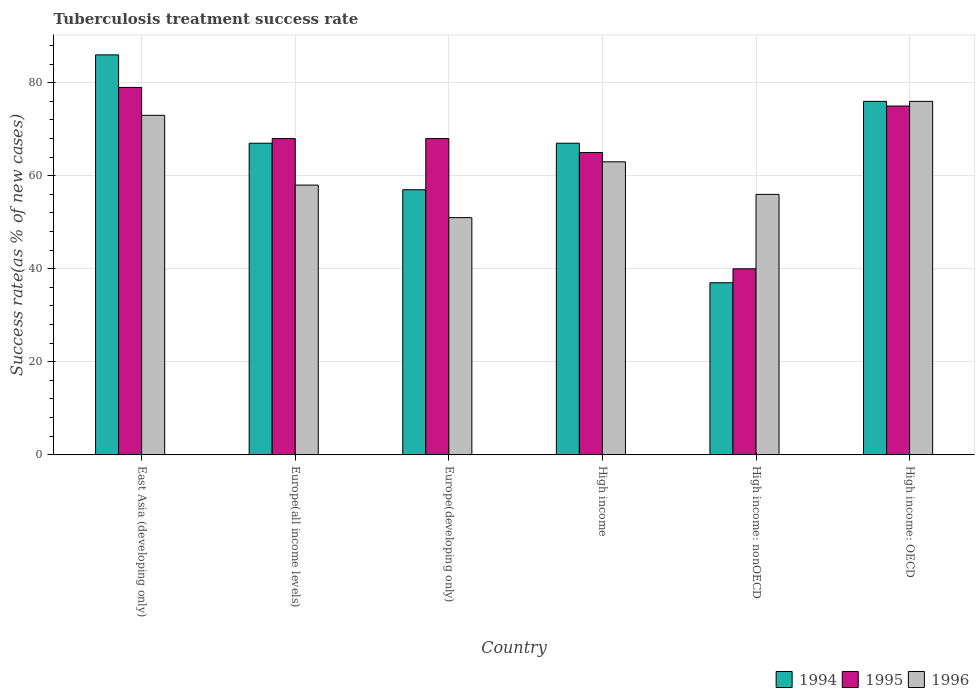How many different coloured bars are there?
Provide a short and direct response. 3. How many groups of bars are there?
Offer a very short reply. 6. Are the number of bars on each tick of the X-axis equal?
Keep it short and to the point. Yes. How many bars are there on the 3rd tick from the right?
Your answer should be compact. 3. What is the label of the 5th group of bars from the left?
Make the answer very short. High income: nonOECD. What is the tuberculosis treatment success rate in 1994 in High income: OECD?
Your answer should be very brief. 76. Across all countries, what is the maximum tuberculosis treatment success rate in 1994?
Your answer should be very brief. 86. In which country was the tuberculosis treatment success rate in 1996 maximum?
Provide a short and direct response. High income: OECD. In which country was the tuberculosis treatment success rate in 1994 minimum?
Provide a short and direct response. High income: nonOECD. What is the total tuberculosis treatment success rate in 1996 in the graph?
Offer a terse response. 377. What is the average tuberculosis treatment success rate in 1996 per country?
Offer a very short reply. 62.83. What is the difference between the tuberculosis treatment success rate of/in 1994 and tuberculosis treatment success rate of/in 1995 in High income: nonOECD?
Keep it short and to the point. -3. What is the ratio of the tuberculosis treatment success rate in 1995 in East Asia (developing only) to that in High income: nonOECD?
Provide a succinct answer. 1.98. What is the difference between the highest and the second highest tuberculosis treatment success rate in 1994?
Provide a short and direct response. -9. In how many countries, is the tuberculosis treatment success rate in 1995 greater than the average tuberculosis treatment success rate in 1995 taken over all countries?
Make the answer very short. 4. Is the sum of the tuberculosis treatment success rate in 1995 in Europe(developing only) and High income greater than the maximum tuberculosis treatment success rate in 1994 across all countries?
Your answer should be very brief. Yes. What does the 1st bar from the right in High income: nonOECD represents?
Give a very brief answer. 1996. How many countries are there in the graph?
Keep it short and to the point. 6. Does the graph contain any zero values?
Make the answer very short. No. How are the legend labels stacked?
Give a very brief answer. Horizontal. What is the title of the graph?
Provide a succinct answer. Tuberculosis treatment success rate. Does "2004" appear as one of the legend labels in the graph?
Your response must be concise. No. What is the label or title of the X-axis?
Give a very brief answer. Country. What is the label or title of the Y-axis?
Provide a short and direct response. Success rate(as % of new cases). What is the Success rate(as % of new cases) in 1994 in East Asia (developing only)?
Keep it short and to the point. 86. What is the Success rate(as % of new cases) in 1995 in East Asia (developing only)?
Provide a succinct answer. 79. What is the Success rate(as % of new cases) of 1994 in Europe(all income levels)?
Provide a short and direct response. 67. What is the Success rate(as % of new cases) of 1995 in Europe(all income levels)?
Offer a terse response. 68. What is the Success rate(as % of new cases) in 1996 in Europe(all income levels)?
Offer a terse response. 58. What is the Success rate(as % of new cases) of 1996 in Europe(developing only)?
Offer a very short reply. 51. What is the Success rate(as % of new cases) of 1995 in High income?
Ensure brevity in your answer.  65. What is the Success rate(as % of new cases) in 1996 in High income?
Offer a very short reply. 63. What is the Success rate(as % of new cases) in 1996 in High income: nonOECD?
Ensure brevity in your answer.  56. What is the Success rate(as % of new cases) in 1994 in High income: OECD?
Make the answer very short. 76. Across all countries, what is the maximum Success rate(as % of new cases) in 1995?
Offer a terse response. 79. Across all countries, what is the maximum Success rate(as % of new cases) of 1996?
Provide a succinct answer. 76. Across all countries, what is the minimum Success rate(as % of new cases) of 1994?
Your answer should be very brief. 37. What is the total Success rate(as % of new cases) of 1994 in the graph?
Provide a succinct answer. 390. What is the total Success rate(as % of new cases) of 1995 in the graph?
Keep it short and to the point. 395. What is the total Success rate(as % of new cases) in 1996 in the graph?
Keep it short and to the point. 377. What is the difference between the Success rate(as % of new cases) in 1996 in East Asia (developing only) and that in Europe(all income levels)?
Your answer should be very brief. 15. What is the difference between the Success rate(as % of new cases) in 1995 in East Asia (developing only) and that in High income?
Your answer should be very brief. 14. What is the difference between the Success rate(as % of new cases) in 1996 in East Asia (developing only) and that in High income?
Your answer should be compact. 10. What is the difference between the Success rate(as % of new cases) of 1996 in East Asia (developing only) and that in High income: nonOECD?
Offer a terse response. 17. What is the difference between the Success rate(as % of new cases) of 1994 in East Asia (developing only) and that in High income: OECD?
Offer a terse response. 10. What is the difference between the Success rate(as % of new cases) of 1995 in East Asia (developing only) and that in High income: OECD?
Make the answer very short. 4. What is the difference between the Success rate(as % of new cases) in 1994 in Europe(all income levels) and that in High income?
Your answer should be compact. 0. What is the difference between the Success rate(as % of new cases) in 1995 in Europe(all income levels) and that in High income?
Keep it short and to the point. 3. What is the difference between the Success rate(as % of new cases) in 1996 in Europe(all income levels) and that in High income: nonOECD?
Your response must be concise. 2. What is the difference between the Success rate(as % of new cases) of 1996 in Europe(all income levels) and that in High income: OECD?
Ensure brevity in your answer.  -18. What is the difference between the Success rate(as % of new cases) of 1994 in Europe(developing only) and that in High income: nonOECD?
Your answer should be compact. 20. What is the difference between the Success rate(as % of new cases) in 1995 in Europe(developing only) and that in High income: nonOECD?
Your response must be concise. 28. What is the difference between the Success rate(as % of new cases) of 1996 in Europe(developing only) and that in High income: nonOECD?
Keep it short and to the point. -5. What is the difference between the Success rate(as % of new cases) in 1994 in Europe(developing only) and that in High income: OECD?
Your answer should be very brief. -19. What is the difference between the Success rate(as % of new cases) of 1996 in Europe(developing only) and that in High income: OECD?
Make the answer very short. -25. What is the difference between the Success rate(as % of new cases) in 1994 in High income and that in High income: nonOECD?
Offer a terse response. 30. What is the difference between the Success rate(as % of new cases) in 1995 in High income and that in High income: nonOECD?
Provide a succinct answer. 25. What is the difference between the Success rate(as % of new cases) of 1996 in High income and that in High income: nonOECD?
Your answer should be very brief. 7. What is the difference between the Success rate(as % of new cases) of 1994 in High income and that in High income: OECD?
Make the answer very short. -9. What is the difference between the Success rate(as % of new cases) in 1995 in High income and that in High income: OECD?
Provide a succinct answer. -10. What is the difference between the Success rate(as % of new cases) in 1994 in High income: nonOECD and that in High income: OECD?
Ensure brevity in your answer.  -39. What is the difference between the Success rate(as % of new cases) of 1995 in High income: nonOECD and that in High income: OECD?
Your answer should be very brief. -35. What is the difference between the Success rate(as % of new cases) of 1994 in East Asia (developing only) and the Success rate(as % of new cases) of 1995 in Europe(all income levels)?
Ensure brevity in your answer.  18. What is the difference between the Success rate(as % of new cases) in 1994 in East Asia (developing only) and the Success rate(as % of new cases) in 1996 in Europe(all income levels)?
Keep it short and to the point. 28. What is the difference between the Success rate(as % of new cases) of 1995 in East Asia (developing only) and the Success rate(as % of new cases) of 1996 in Europe(developing only)?
Provide a short and direct response. 28. What is the difference between the Success rate(as % of new cases) in 1995 in East Asia (developing only) and the Success rate(as % of new cases) in 1996 in High income?
Your response must be concise. 16. What is the difference between the Success rate(as % of new cases) of 1994 in East Asia (developing only) and the Success rate(as % of new cases) of 1995 in High income: nonOECD?
Ensure brevity in your answer.  46. What is the difference between the Success rate(as % of new cases) in 1994 in Europe(all income levels) and the Success rate(as % of new cases) in 1995 in Europe(developing only)?
Offer a terse response. -1. What is the difference between the Success rate(as % of new cases) in 1995 in Europe(all income levels) and the Success rate(as % of new cases) in 1996 in Europe(developing only)?
Ensure brevity in your answer.  17. What is the difference between the Success rate(as % of new cases) in 1994 in Europe(all income levels) and the Success rate(as % of new cases) in 1995 in High income?
Offer a very short reply. 2. What is the difference between the Success rate(as % of new cases) in 1995 in Europe(all income levels) and the Success rate(as % of new cases) in 1996 in High income?
Keep it short and to the point. 5. What is the difference between the Success rate(as % of new cases) of 1994 in Europe(all income levels) and the Success rate(as % of new cases) of 1996 in High income: nonOECD?
Provide a short and direct response. 11. What is the difference between the Success rate(as % of new cases) of 1995 in Europe(all income levels) and the Success rate(as % of new cases) of 1996 in High income: nonOECD?
Provide a succinct answer. 12. What is the difference between the Success rate(as % of new cases) of 1994 in Europe(all income levels) and the Success rate(as % of new cases) of 1995 in High income: OECD?
Give a very brief answer. -8. What is the difference between the Success rate(as % of new cases) in 1995 in Europe(developing only) and the Success rate(as % of new cases) in 1996 in High income?
Ensure brevity in your answer.  5. What is the difference between the Success rate(as % of new cases) of 1994 in Europe(developing only) and the Success rate(as % of new cases) of 1995 in High income: nonOECD?
Provide a succinct answer. 17. What is the difference between the Success rate(as % of new cases) of 1994 in Europe(developing only) and the Success rate(as % of new cases) of 1996 in High income: nonOECD?
Keep it short and to the point. 1. What is the difference between the Success rate(as % of new cases) of 1995 in Europe(developing only) and the Success rate(as % of new cases) of 1996 in High income: OECD?
Offer a terse response. -8. What is the difference between the Success rate(as % of new cases) of 1994 in High income and the Success rate(as % of new cases) of 1995 in High income: nonOECD?
Your answer should be very brief. 27. What is the difference between the Success rate(as % of new cases) in 1994 in High income and the Success rate(as % of new cases) in 1996 in High income: nonOECD?
Make the answer very short. 11. What is the difference between the Success rate(as % of new cases) in 1994 in High income and the Success rate(as % of new cases) in 1995 in High income: OECD?
Offer a very short reply. -8. What is the difference between the Success rate(as % of new cases) of 1994 in High income: nonOECD and the Success rate(as % of new cases) of 1995 in High income: OECD?
Your answer should be very brief. -38. What is the difference between the Success rate(as % of new cases) in 1994 in High income: nonOECD and the Success rate(as % of new cases) in 1996 in High income: OECD?
Offer a terse response. -39. What is the difference between the Success rate(as % of new cases) of 1995 in High income: nonOECD and the Success rate(as % of new cases) of 1996 in High income: OECD?
Offer a very short reply. -36. What is the average Success rate(as % of new cases) of 1994 per country?
Provide a short and direct response. 65. What is the average Success rate(as % of new cases) of 1995 per country?
Offer a very short reply. 65.83. What is the average Success rate(as % of new cases) in 1996 per country?
Ensure brevity in your answer.  62.83. What is the difference between the Success rate(as % of new cases) in 1995 and Success rate(as % of new cases) in 1996 in East Asia (developing only)?
Offer a very short reply. 6. What is the difference between the Success rate(as % of new cases) in 1994 and Success rate(as % of new cases) in 1996 in Europe(all income levels)?
Your answer should be compact. 9. What is the difference between the Success rate(as % of new cases) of 1994 and Success rate(as % of new cases) of 1996 in Europe(developing only)?
Provide a short and direct response. 6. What is the difference between the Success rate(as % of new cases) of 1994 and Success rate(as % of new cases) of 1996 in High income: OECD?
Provide a succinct answer. 0. What is the ratio of the Success rate(as % of new cases) of 1994 in East Asia (developing only) to that in Europe(all income levels)?
Provide a succinct answer. 1.28. What is the ratio of the Success rate(as % of new cases) of 1995 in East Asia (developing only) to that in Europe(all income levels)?
Keep it short and to the point. 1.16. What is the ratio of the Success rate(as % of new cases) in 1996 in East Asia (developing only) to that in Europe(all income levels)?
Ensure brevity in your answer.  1.26. What is the ratio of the Success rate(as % of new cases) of 1994 in East Asia (developing only) to that in Europe(developing only)?
Provide a short and direct response. 1.51. What is the ratio of the Success rate(as % of new cases) of 1995 in East Asia (developing only) to that in Europe(developing only)?
Provide a succinct answer. 1.16. What is the ratio of the Success rate(as % of new cases) of 1996 in East Asia (developing only) to that in Europe(developing only)?
Make the answer very short. 1.43. What is the ratio of the Success rate(as % of new cases) of 1994 in East Asia (developing only) to that in High income?
Offer a terse response. 1.28. What is the ratio of the Success rate(as % of new cases) in 1995 in East Asia (developing only) to that in High income?
Your answer should be compact. 1.22. What is the ratio of the Success rate(as % of new cases) in 1996 in East Asia (developing only) to that in High income?
Your answer should be very brief. 1.16. What is the ratio of the Success rate(as % of new cases) of 1994 in East Asia (developing only) to that in High income: nonOECD?
Offer a very short reply. 2.32. What is the ratio of the Success rate(as % of new cases) of 1995 in East Asia (developing only) to that in High income: nonOECD?
Your response must be concise. 1.98. What is the ratio of the Success rate(as % of new cases) of 1996 in East Asia (developing only) to that in High income: nonOECD?
Provide a succinct answer. 1.3. What is the ratio of the Success rate(as % of new cases) of 1994 in East Asia (developing only) to that in High income: OECD?
Offer a very short reply. 1.13. What is the ratio of the Success rate(as % of new cases) in 1995 in East Asia (developing only) to that in High income: OECD?
Your answer should be compact. 1.05. What is the ratio of the Success rate(as % of new cases) in 1996 in East Asia (developing only) to that in High income: OECD?
Provide a succinct answer. 0.96. What is the ratio of the Success rate(as % of new cases) of 1994 in Europe(all income levels) to that in Europe(developing only)?
Offer a terse response. 1.18. What is the ratio of the Success rate(as % of new cases) of 1996 in Europe(all income levels) to that in Europe(developing only)?
Make the answer very short. 1.14. What is the ratio of the Success rate(as % of new cases) in 1995 in Europe(all income levels) to that in High income?
Offer a very short reply. 1.05. What is the ratio of the Success rate(as % of new cases) in 1996 in Europe(all income levels) to that in High income?
Your response must be concise. 0.92. What is the ratio of the Success rate(as % of new cases) of 1994 in Europe(all income levels) to that in High income: nonOECD?
Your response must be concise. 1.81. What is the ratio of the Success rate(as % of new cases) in 1996 in Europe(all income levels) to that in High income: nonOECD?
Give a very brief answer. 1.04. What is the ratio of the Success rate(as % of new cases) of 1994 in Europe(all income levels) to that in High income: OECD?
Your answer should be very brief. 0.88. What is the ratio of the Success rate(as % of new cases) in 1995 in Europe(all income levels) to that in High income: OECD?
Provide a succinct answer. 0.91. What is the ratio of the Success rate(as % of new cases) of 1996 in Europe(all income levels) to that in High income: OECD?
Your answer should be very brief. 0.76. What is the ratio of the Success rate(as % of new cases) of 1994 in Europe(developing only) to that in High income?
Offer a very short reply. 0.85. What is the ratio of the Success rate(as % of new cases) of 1995 in Europe(developing only) to that in High income?
Offer a terse response. 1.05. What is the ratio of the Success rate(as % of new cases) of 1996 in Europe(developing only) to that in High income?
Make the answer very short. 0.81. What is the ratio of the Success rate(as % of new cases) of 1994 in Europe(developing only) to that in High income: nonOECD?
Provide a succinct answer. 1.54. What is the ratio of the Success rate(as % of new cases) in 1996 in Europe(developing only) to that in High income: nonOECD?
Make the answer very short. 0.91. What is the ratio of the Success rate(as % of new cases) of 1995 in Europe(developing only) to that in High income: OECD?
Your answer should be very brief. 0.91. What is the ratio of the Success rate(as % of new cases) in 1996 in Europe(developing only) to that in High income: OECD?
Ensure brevity in your answer.  0.67. What is the ratio of the Success rate(as % of new cases) in 1994 in High income to that in High income: nonOECD?
Ensure brevity in your answer.  1.81. What is the ratio of the Success rate(as % of new cases) in 1995 in High income to that in High income: nonOECD?
Keep it short and to the point. 1.62. What is the ratio of the Success rate(as % of new cases) of 1994 in High income to that in High income: OECD?
Provide a short and direct response. 0.88. What is the ratio of the Success rate(as % of new cases) of 1995 in High income to that in High income: OECD?
Make the answer very short. 0.87. What is the ratio of the Success rate(as % of new cases) in 1996 in High income to that in High income: OECD?
Offer a very short reply. 0.83. What is the ratio of the Success rate(as % of new cases) in 1994 in High income: nonOECD to that in High income: OECD?
Provide a short and direct response. 0.49. What is the ratio of the Success rate(as % of new cases) in 1995 in High income: nonOECD to that in High income: OECD?
Ensure brevity in your answer.  0.53. What is the ratio of the Success rate(as % of new cases) in 1996 in High income: nonOECD to that in High income: OECD?
Your answer should be compact. 0.74. What is the difference between the highest and the second highest Success rate(as % of new cases) of 1994?
Offer a very short reply. 10. What is the difference between the highest and the lowest Success rate(as % of new cases) of 1996?
Provide a succinct answer. 25. 